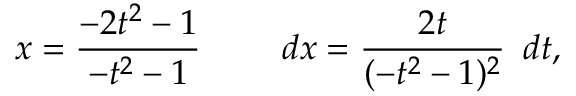<formula> <loc_0><loc_0><loc_500><loc_500>x = { \frac { - 2 t ^ { 2 } - 1 } { - t ^ { 2 } - 1 } } \quad \ d x = { \frac { 2 t } { ( - t ^ { 2 } - 1 ) ^ { 2 } } } \, \ d t ,</formula> 